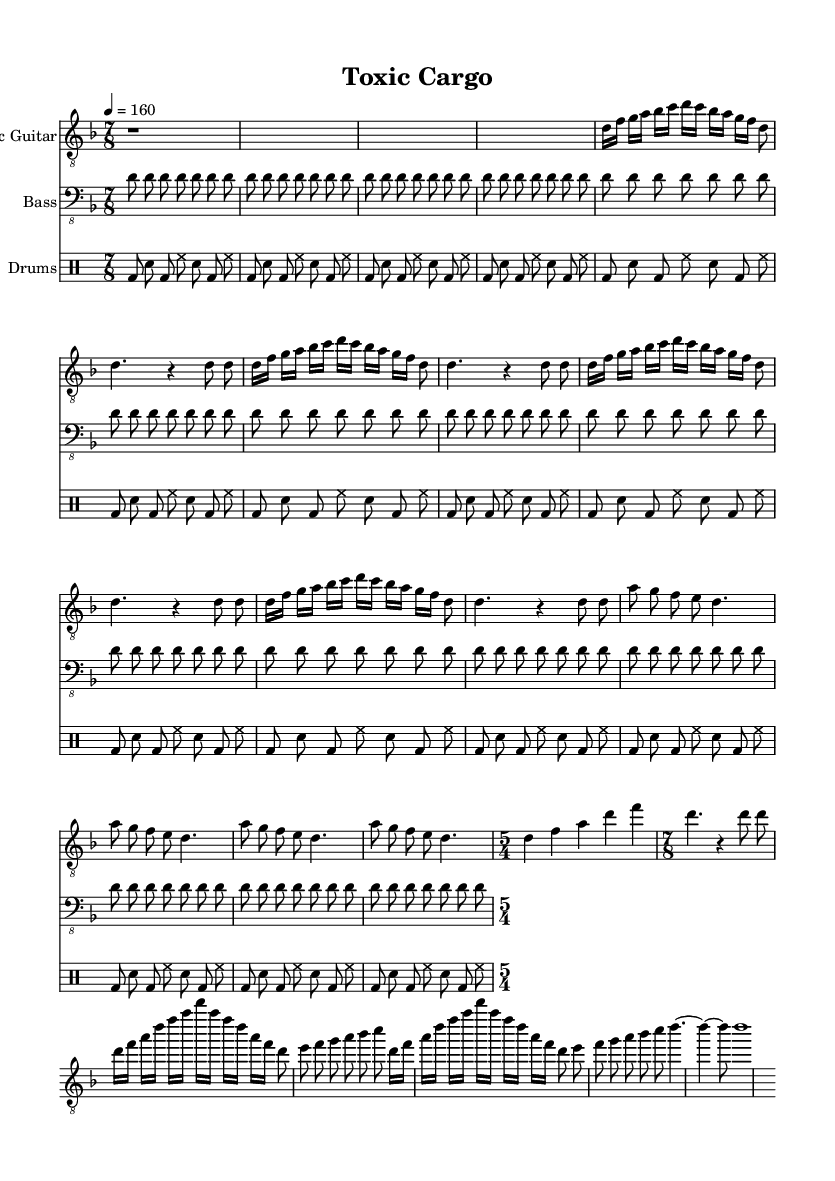What is the key signature of this music? The key signature is D minor, indicated at the beginning of the score. There are one flat (B♭) present in the key signature, defining D minor's characteristics.
Answer: D minor What is the time signature of the composition? The time signature changes, but the primary one specified is 7/8, as shown at the start of the piece. This indicates a measure that consists of 7 eighth notes in each bar.
Answer: 7/8 What is the tempo marking for this piece? The tempo marking is specified as quarter note equals 160, meaning the tempo is quite fast and energetic. It is indicated at the beginning of the score.
Answer: 160 How many measures are there in the verse section? The verse is repeated 4 times and structured with one measure of 8 eighth notes (or equivalent notes), resulting in a total of 4 measures in that section.
Answer: 4 What is the main thematic focus in the chorus? The chorus features a descending melodic line that emphasizes the notes A, G, F, E, and D, indicating a clear and powerful thematic development typical in metal music to convey strong emotions or ideas.
Answer: A, G, F, E, D How many times is the drum pattern repeated in the entire song? The drum pattern is repeated 16 times throughout the song, as indicated in the drumming section of the score and its repetition section.
Answer: 16 Which instrument plays the solo section? The solo section is designated for the Electric Guitar, as shown in the staff naming and musical contents focusing on this instrument during the solo part.
Answer: Electric Guitar 